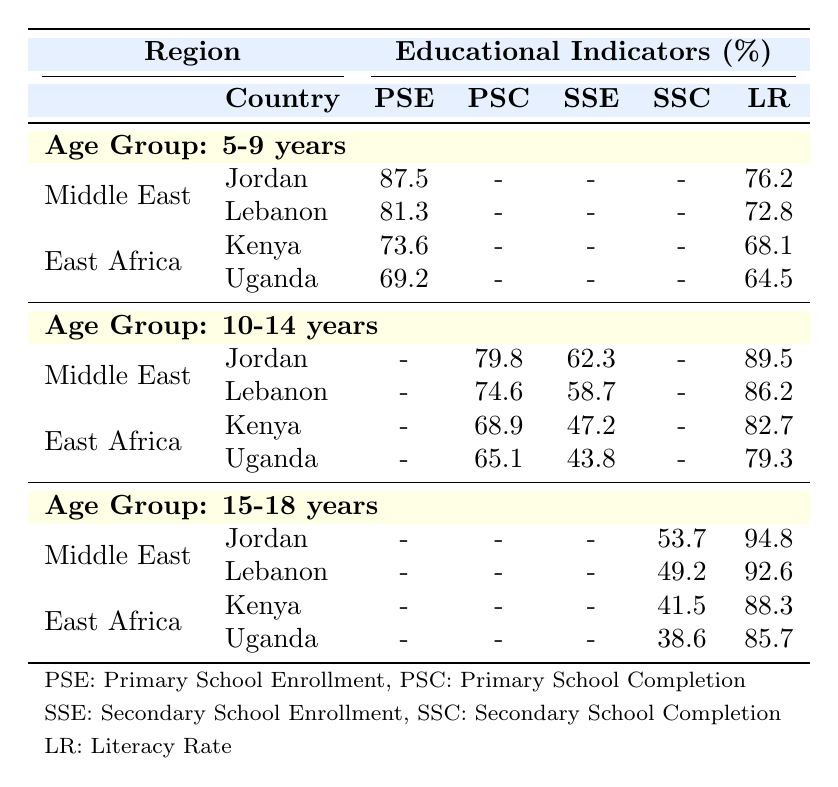What is the primary school enrollment percentage for Jordan in the 5-9 age group? The table shows that Jordan's primary school enrollment for the 5-9 age group is listed as 87.5%.
Answer: 87.5% Which country in East Africa has the highest literacy rate among 5-9-year-olds? Looking at the literacy rates for the 5-9 age group in East Africa, Kenya has a literacy rate of 68.1%, while Uganda has 64.5%. Therefore, Kenya has the highest literacy rate.
Answer: Kenya What is the difference in secondary school enrollment between Jordan and Lebanon for the 10-14 age group? Jordan's secondary school enrollment is 62.3% and Lebanon's is 58.7%. The difference is 62.3% - 58.7% = 3.6%.
Answer: 3.6% Is the literacy rate for girls in the 15-18 age group in Jordan higher than 90%? The literacy rate for 15-18-year-olds in Jordan is 94.8%, which is indeed higher than 90%.
Answer: Yes What is the average primary school enrollment for both countries in East Africa among 5-9-year-olds? The primary school enrollment for Kenya is 73.6% and for Uganda is 69.2%. Adding these gives 73.6 + 69.2 = 142.8%. Dividing by 2 gives an average of 142.8 / 2 = 71.4%.
Answer: 71.4% Which country has a higher secondary school completion rate for 15-18-year-olds, Jordan or Lebanon? The secondary school completion rate in Jordan is 53.7% compared to Lebanon's 49.2%. Hence, Jordan has a higher rate.
Answer: Jordan How many countries in the Middle East reported primary school completion percentages in the 10-14 age group? The table includes two countries in the Middle East, Jordan and Lebanon, both reporting primary school completion percentages for the 10-14 age group.
Answer: Two What is the overall trend in literacy rates from the 5-9 to the 15-18 age group for Jordan? The literacy rates in Jordan increase from 76.2% in the 5-9 age group to 94.8% in the 15-18 age group, showing a positive trend.
Answer: Positive trend Is the vocational training enrollment for Uganda higher or lower than the literacy rate for Kenya in the 15-18 age group? Uganda's vocational training enrollment is 11.2% while Kenya's literacy rate is 88.3%. Since 11.2% is lower than 88.3%, it is lower.
Answer: Lower What percentage of 10-14-year-olds in Uganda are enrolled in secondary school? According to the table, Uganda's secondary school enrollment for the 10-14 age group is 43.8%.
Answer: 43.8% 